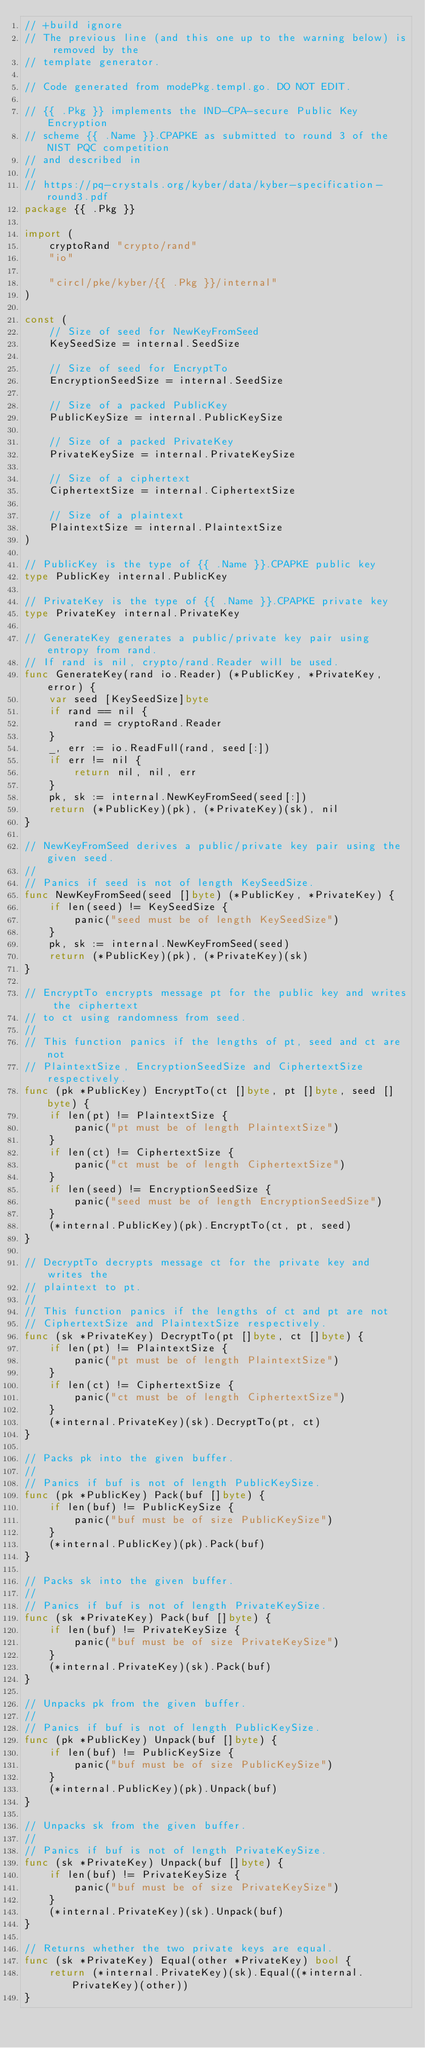Convert code to text. <code><loc_0><loc_0><loc_500><loc_500><_Go_>// +build ignore
// The previous line (and this one up to the warning below) is removed by the
// template generator.

// Code generated from modePkg.templ.go. DO NOT EDIT.

// {{ .Pkg }} implements the IND-CPA-secure Public Key Encryption
// scheme {{ .Name }}.CPAPKE as submitted to round 3 of the NIST PQC competition
// and described in
//
// https://pq-crystals.org/kyber/data/kyber-specification-round3.pdf
package {{ .Pkg }}

import (
	cryptoRand "crypto/rand"
	"io"

	"circl/pke/kyber/{{ .Pkg }}/internal"
)

const (
	// Size of seed for NewKeyFromSeed
	KeySeedSize = internal.SeedSize

	// Size of seed for EncryptTo
	EncryptionSeedSize = internal.SeedSize

	// Size of a packed PublicKey
	PublicKeySize = internal.PublicKeySize

	// Size of a packed PrivateKey
	PrivateKeySize = internal.PrivateKeySize

	// Size of a ciphertext
	CiphertextSize = internal.CiphertextSize

	// Size of a plaintext
	PlaintextSize = internal.PlaintextSize
)

// PublicKey is the type of {{ .Name }}.CPAPKE public key
type PublicKey internal.PublicKey

// PrivateKey is the type of {{ .Name }}.CPAPKE private key
type PrivateKey internal.PrivateKey

// GenerateKey generates a public/private key pair using entropy from rand.
// If rand is nil, crypto/rand.Reader will be used.
func GenerateKey(rand io.Reader) (*PublicKey, *PrivateKey, error) {
	var seed [KeySeedSize]byte
	if rand == nil {
		rand = cryptoRand.Reader
	}
	_, err := io.ReadFull(rand, seed[:])
	if err != nil {
		return nil, nil, err
	}
	pk, sk := internal.NewKeyFromSeed(seed[:])
	return (*PublicKey)(pk), (*PrivateKey)(sk), nil
}

// NewKeyFromSeed derives a public/private key pair using the given seed.
//
// Panics if seed is not of length KeySeedSize.
func NewKeyFromSeed(seed []byte) (*PublicKey, *PrivateKey) {
	if len(seed) != KeySeedSize {
		panic("seed must be of length KeySeedSize")
	}
	pk, sk := internal.NewKeyFromSeed(seed)
	return (*PublicKey)(pk), (*PrivateKey)(sk)
}

// EncryptTo encrypts message pt for the public key and writes the ciphertext
// to ct using randomness from seed.
//
// This function panics if the lengths of pt, seed and ct are not
// PlaintextSize, EncryptionSeedSize and CiphertextSize respectively.
func (pk *PublicKey) EncryptTo(ct []byte, pt []byte, seed []byte) {
	if len(pt) != PlaintextSize {
		panic("pt must be of length PlaintextSize")
	}
	if len(ct) != CiphertextSize {
		panic("ct must be of length CiphertextSize")
	}
	if len(seed) != EncryptionSeedSize {
		panic("seed must be of length EncryptionSeedSize")
	}
	(*internal.PublicKey)(pk).EncryptTo(ct, pt, seed)
}

// DecryptTo decrypts message ct for the private key and writes the
// plaintext to pt.
//
// This function panics if the lengths of ct and pt are not
// CiphertextSize and PlaintextSize respectively.
func (sk *PrivateKey) DecryptTo(pt []byte, ct []byte) {
	if len(pt) != PlaintextSize {
		panic("pt must be of length PlaintextSize")
	}
	if len(ct) != CiphertextSize {
		panic("ct must be of length CiphertextSize")
	}
	(*internal.PrivateKey)(sk).DecryptTo(pt, ct)
}

// Packs pk into the given buffer.
//
// Panics if buf is not of length PublicKeySize.
func (pk *PublicKey) Pack(buf []byte) {
	if len(buf) != PublicKeySize {
		panic("buf must be of size PublicKeySize")
	}
	(*internal.PublicKey)(pk).Pack(buf)
}

// Packs sk into the given buffer.
//
// Panics if buf is not of length PrivateKeySize.
func (sk *PrivateKey) Pack(buf []byte) {
	if len(buf) != PrivateKeySize {
		panic("buf must be of size PrivateKeySize")
	}
	(*internal.PrivateKey)(sk).Pack(buf)
}

// Unpacks pk from the given buffer.
//
// Panics if buf is not of length PublicKeySize.
func (pk *PublicKey) Unpack(buf []byte) {
	if len(buf) != PublicKeySize {
		panic("buf must be of size PublicKeySize")
	}
	(*internal.PublicKey)(pk).Unpack(buf)
}

// Unpacks sk from the given buffer.
//
// Panics if buf is not of length PrivateKeySize.
func (sk *PrivateKey) Unpack(buf []byte) {
	if len(buf) != PrivateKeySize {
		panic("buf must be of size PrivateKeySize")
	}
	(*internal.PrivateKey)(sk).Unpack(buf)
}

// Returns whether the two private keys are equal.
func (sk *PrivateKey) Equal(other *PrivateKey) bool {
	return (*internal.PrivateKey)(sk).Equal((*internal.PrivateKey)(other))
}
</code> 